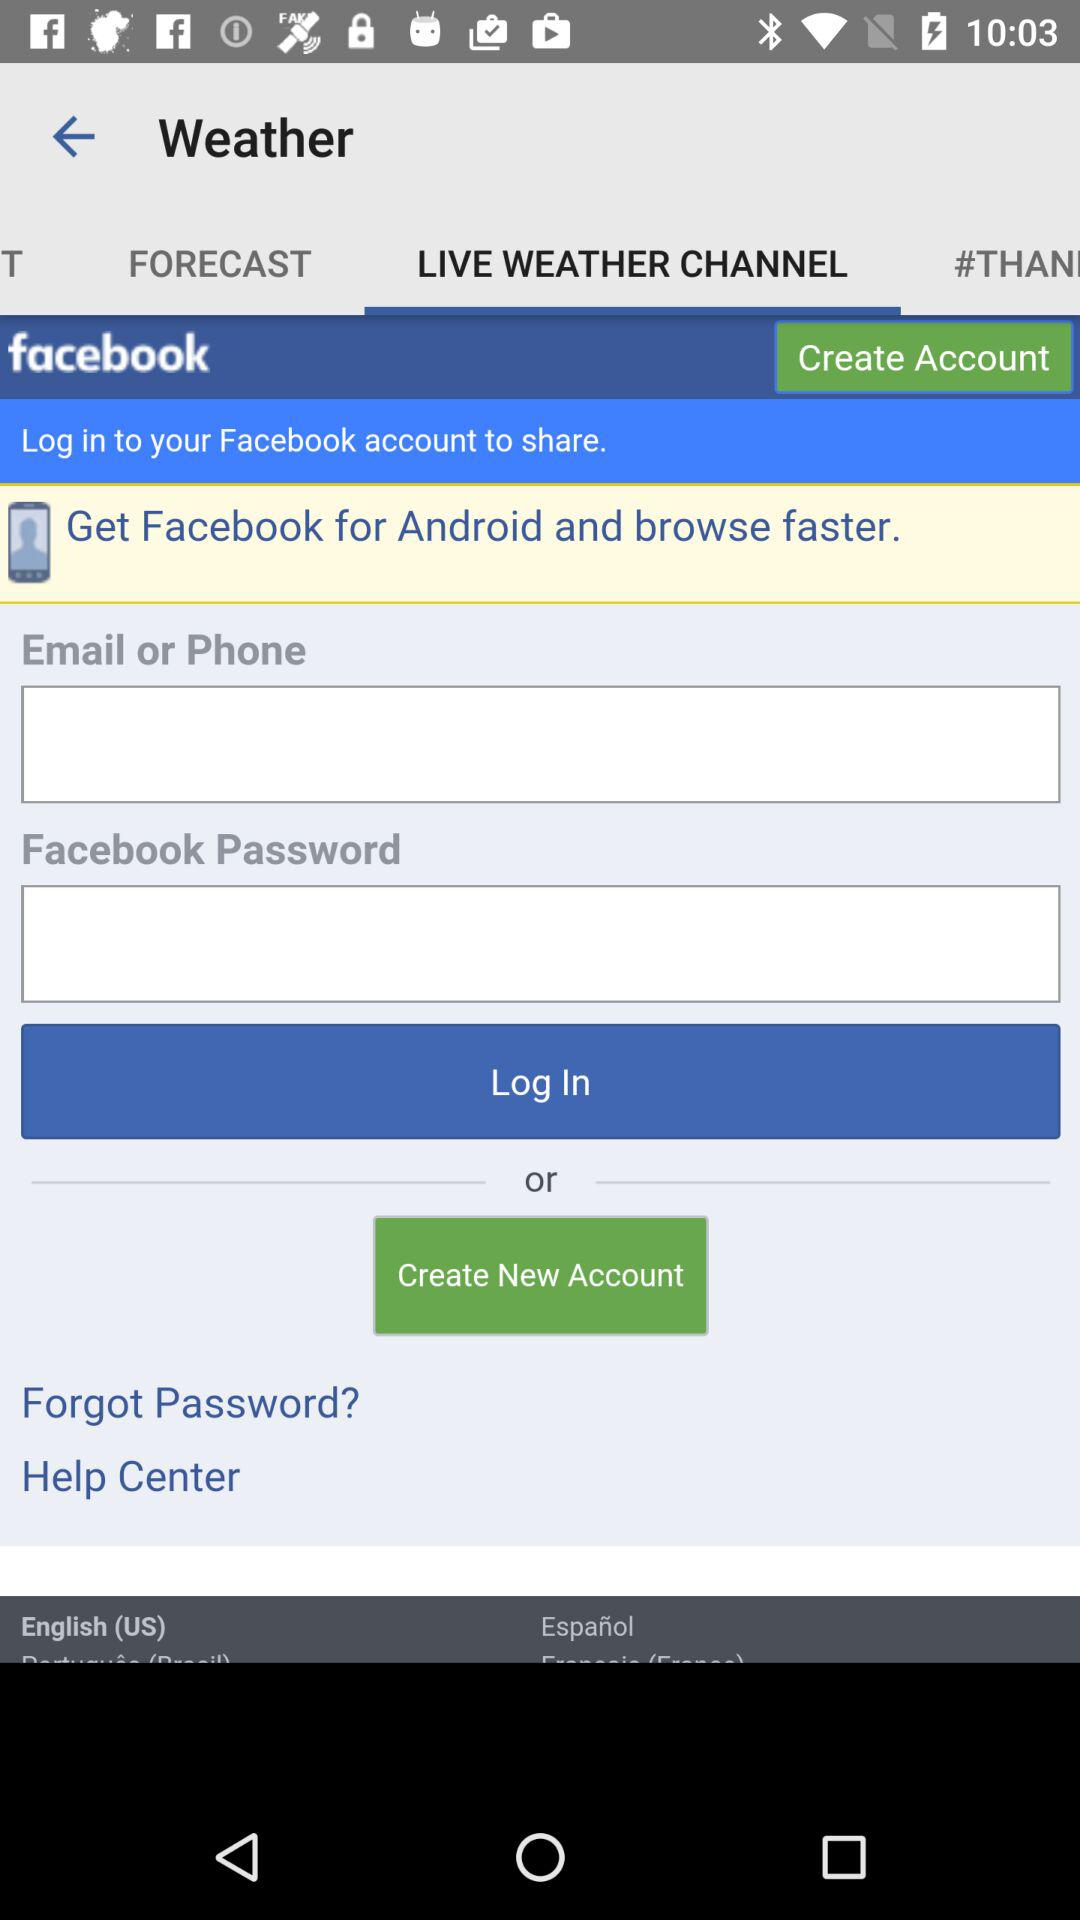What account can be used to login? The account that can be used to login is "facebook". 